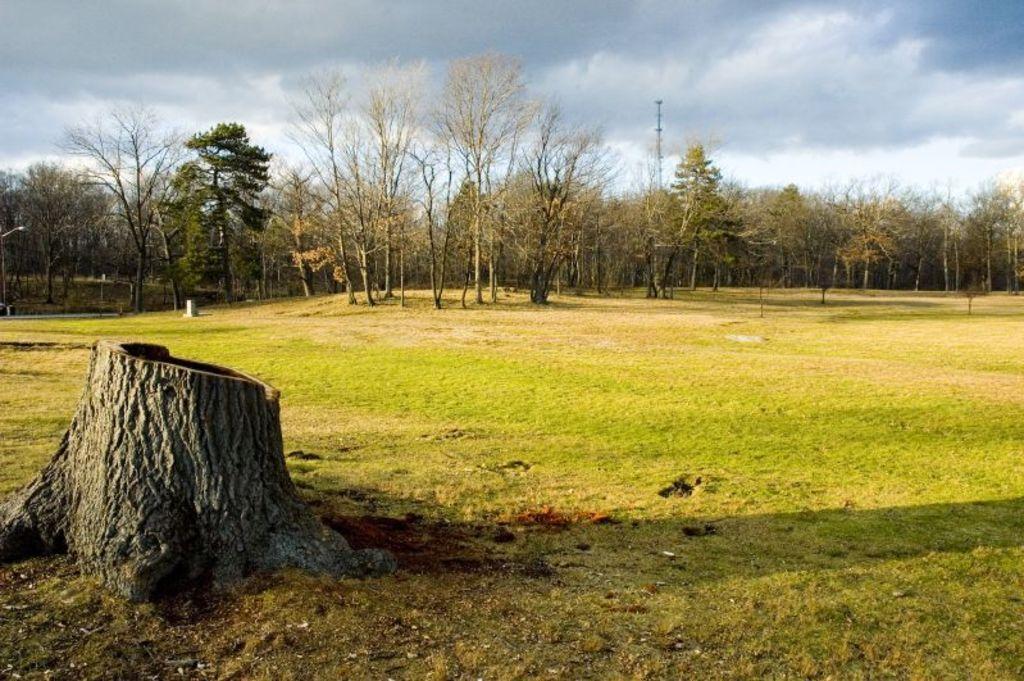How would you summarize this image in a sentence or two? On the left side we can see a trunk on the ground. In the background there are trees, pole and clouds in the sky and we can see a light on the left side. 